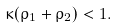Convert formula to latex. <formula><loc_0><loc_0><loc_500><loc_500>\kappa ( \rho _ { 1 } + \rho _ { 2 } ) < 1 .</formula> 